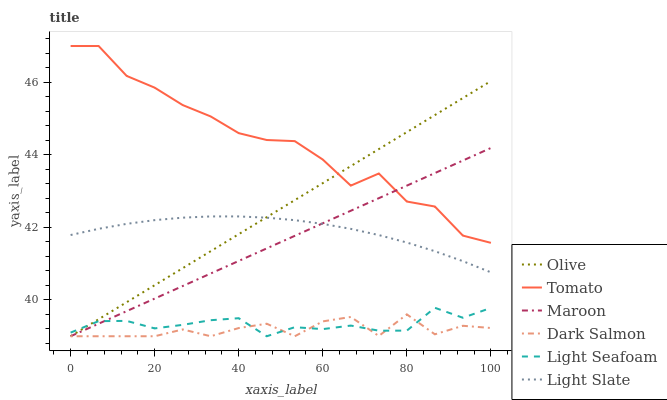Does Dark Salmon have the minimum area under the curve?
Answer yes or no. Yes. Does Tomato have the maximum area under the curve?
Answer yes or no. Yes. Does Light Slate have the minimum area under the curve?
Answer yes or no. No. Does Light Slate have the maximum area under the curve?
Answer yes or no. No. Is Olive the smoothest?
Answer yes or no. Yes. Is Tomato the roughest?
Answer yes or no. Yes. Is Light Slate the smoothest?
Answer yes or no. No. Is Light Slate the roughest?
Answer yes or no. No. Does Light Slate have the lowest value?
Answer yes or no. No. Does Tomato have the highest value?
Answer yes or no. Yes. Does Light Slate have the highest value?
Answer yes or no. No. Is Light Slate less than Tomato?
Answer yes or no. Yes. Is Tomato greater than Dark Salmon?
Answer yes or no. Yes. Does Olive intersect Tomato?
Answer yes or no. Yes. Is Olive less than Tomato?
Answer yes or no. No. Is Olive greater than Tomato?
Answer yes or no. No. Does Light Slate intersect Tomato?
Answer yes or no. No. 